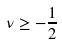Convert formula to latex. <formula><loc_0><loc_0><loc_500><loc_500>\nu \geq - \frac { 1 } { 2 }</formula> 